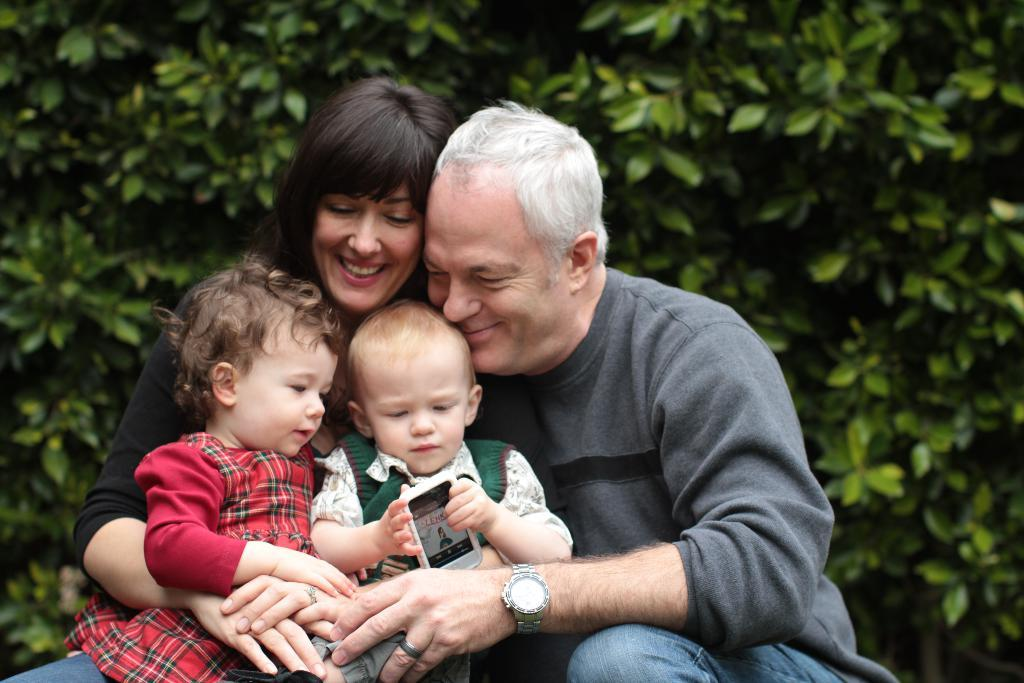Who is present in the picture with the old man? There is a woman in the picture. What is the woman doing in the picture? The woman is sitting with two small babies. How are the people in the picture feeling? The people in the picture are smiling. What can be seen in the background of the picture? There are green plants visible in the background of the picture. What type of mine is visible in the background of the picture? There is no mine present in the background of the picture; it features green plants. What color is the quartz in the woman's shirt? There is no quartz mentioned in the image, and the woman is not wearing a shirt. 